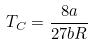<formula> <loc_0><loc_0><loc_500><loc_500>T _ { C } = \frac { 8 a } { 2 7 b R }</formula> 